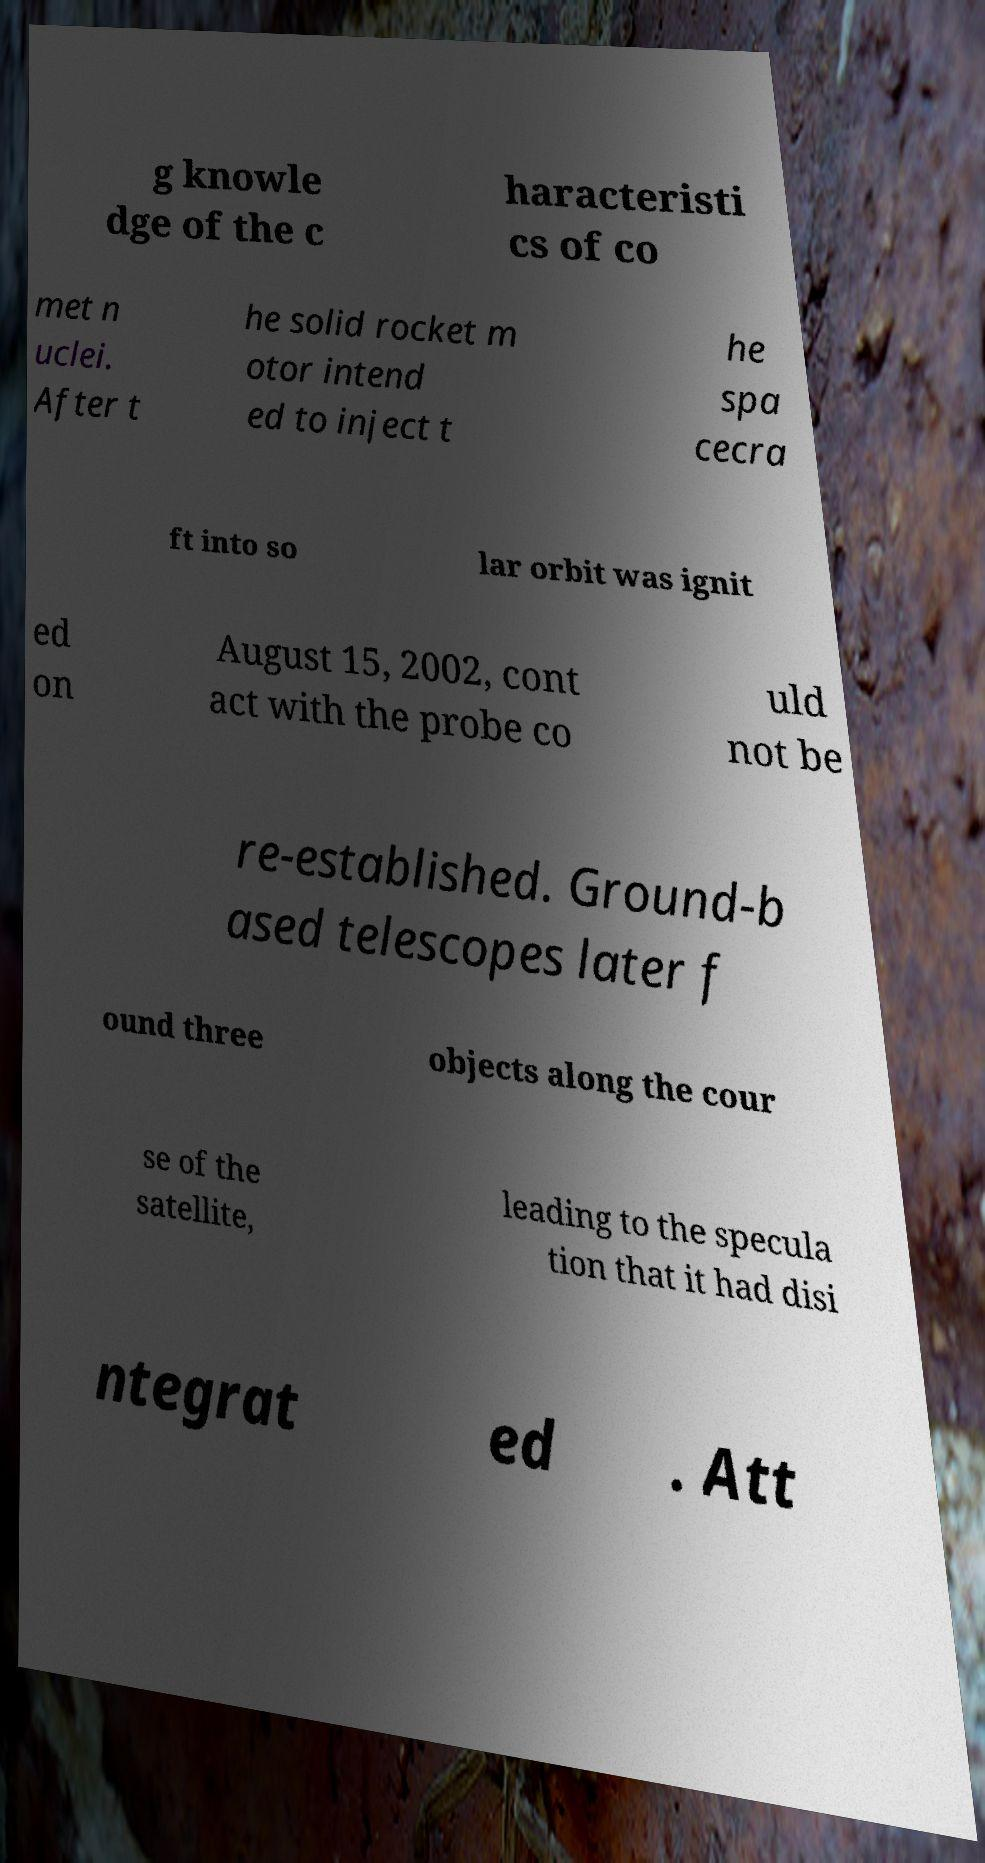Could you extract and type out the text from this image? g knowle dge of the c haracteristi cs of co met n uclei. After t he solid rocket m otor intend ed to inject t he spa cecra ft into so lar orbit was ignit ed on August 15, 2002, cont act with the probe co uld not be re-established. Ground-b ased telescopes later f ound three objects along the cour se of the satellite, leading to the specula tion that it had disi ntegrat ed . Att 